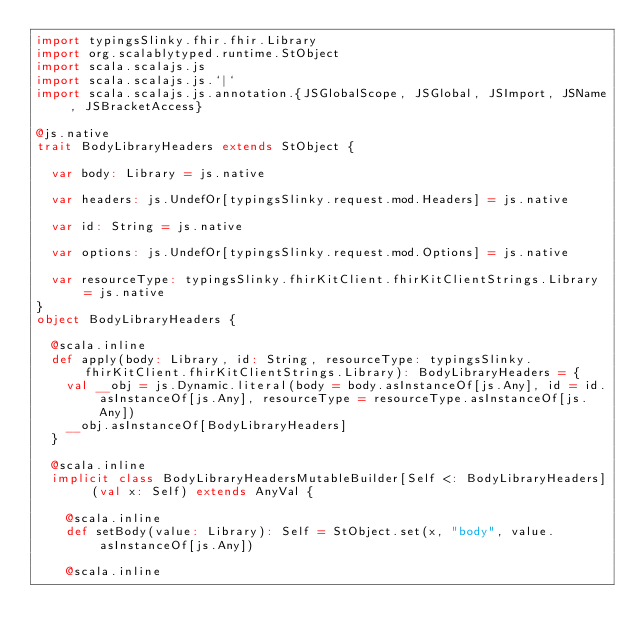<code> <loc_0><loc_0><loc_500><loc_500><_Scala_>import typingsSlinky.fhir.fhir.Library
import org.scalablytyped.runtime.StObject
import scala.scalajs.js
import scala.scalajs.js.`|`
import scala.scalajs.js.annotation.{JSGlobalScope, JSGlobal, JSImport, JSName, JSBracketAccess}

@js.native
trait BodyLibraryHeaders extends StObject {
  
  var body: Library = js.native
  
  var headers: js.UndefOr[typingsSlinky.request.mod.Headers] = js.native
  
  var id: String = js.native
  
  var options: js.UndefOr[typingsSlinky.request.mod.Options] = js.native
  
  var resourceType: typingsSlinky.fhirKitClient.fhirKitClientStrings.Library = js.native
}
object BodyLibraryHeaders {
  
  @scala.inline
  def apply(body: Library, id: String, resourceType: typingsSlinky.fhirKitClient.fhirKitClientStrings.Library): BodyLibraryHeaders = {
    val __obj = js.Dynamic.literal(body = body.asInstanceOf[js.Any], id = id.asInstanceOf[js.Any], resourceType = resourceType.asInstanceOf[js.Any])
    __obj.asInstanceOf[BodyLibraryHeaders]
  }
  
  @scala.inline
  implicit class BodyLibraryHeadersMutableBuilder[Self <: BodyLibraryHeaders] (val x: Self) extends AnyVal {
    
    @scala.inline
    def setBody(value: Library): Self = StObject.set(x, "body", value.asInstanceOf[js.Any])
    
    @scala.inline</code> 